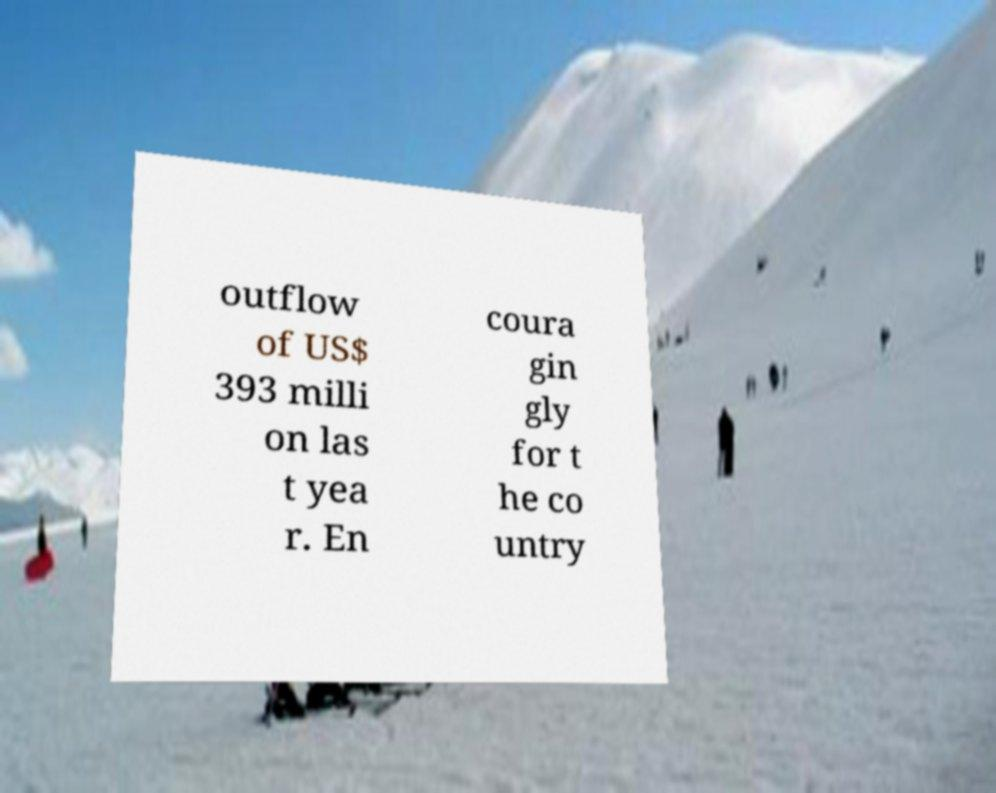Please identify and transcribe the text found in this image. outflow of US$ 393 milli on las t yea r. En coura gin gly for t he co untry 